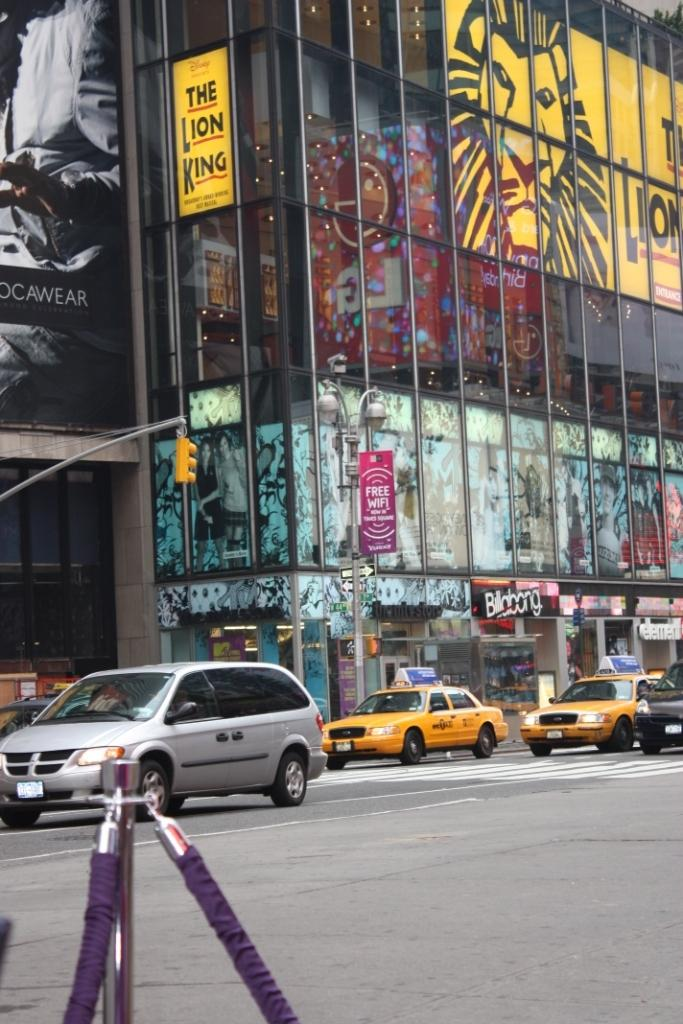<image>
Provide a brief description of the given image. New York City streets in front of The Lion King theater with taxis parked. 